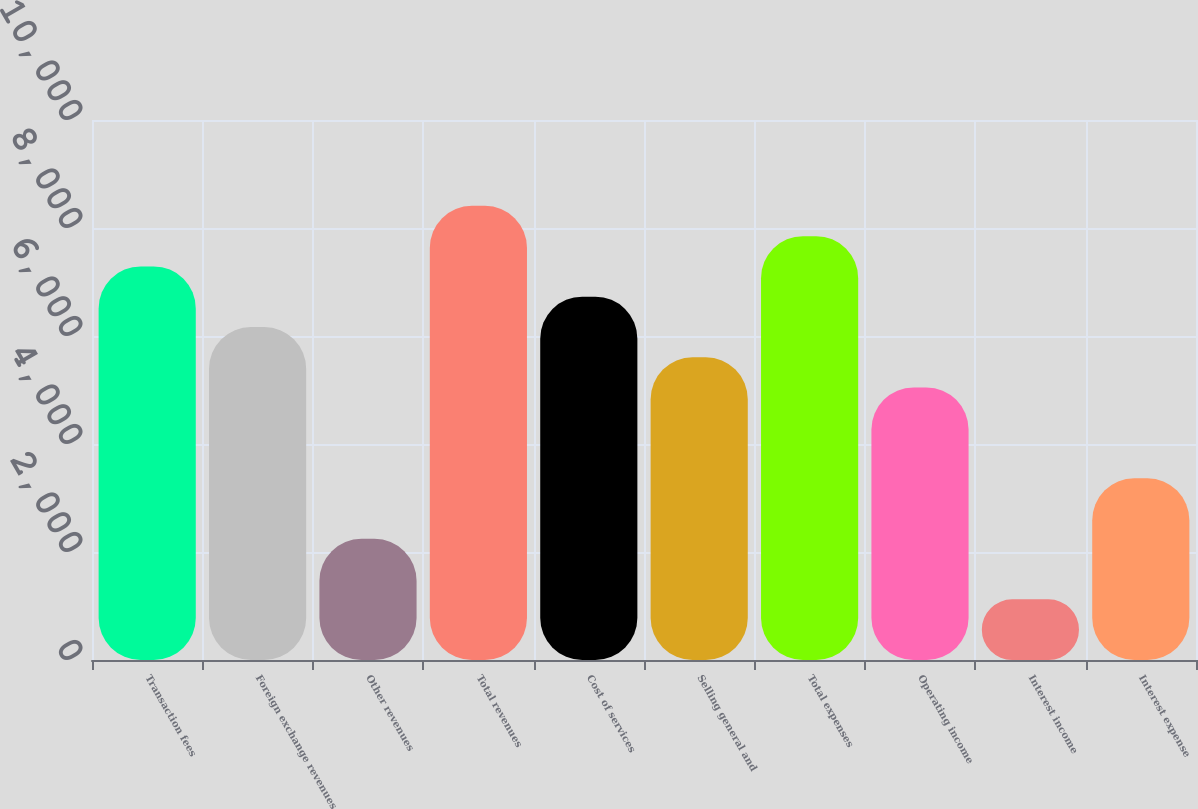Convert chart to OTSL. <chart><loc_0><loc_0><loc_500><loc_500><bar_chart><fcel>Transaction fees<fcel>Foreign exchange revenues<fcel>Other revenues<fcel>Total revenues<fcel>Cost of services<fcel>Selling general and<fcel>Total expenses<fcel>Operating income<fcel>Interest income<fcel>Interest expense<nl><fcel>7288.87<fcel>6167.75<fcel>2243.83<fcel>8409.99<fcel>6728.31<fcel>5607.19<fcel>7849.43<fcel>5046.63<fcel>1122.71<fcel>3364.95<nl></chart> 